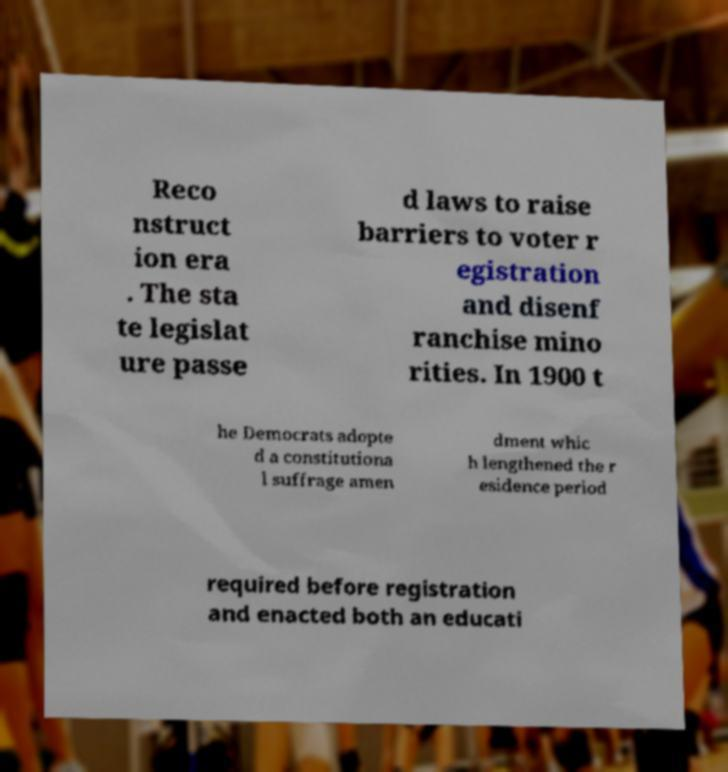For documentation purposes, I need the text within this image transcribed. Could you provide that? Reco nstruct ion era . The sta te legislat ure passe d laws to raise barriers to voter r egistration and disenf ranchise mino rities. In 1900 t he Democrats adopte d a constitutiona l suffrage amen dment whic h lengthened the r esidence period required before registration and enacted both an educati 